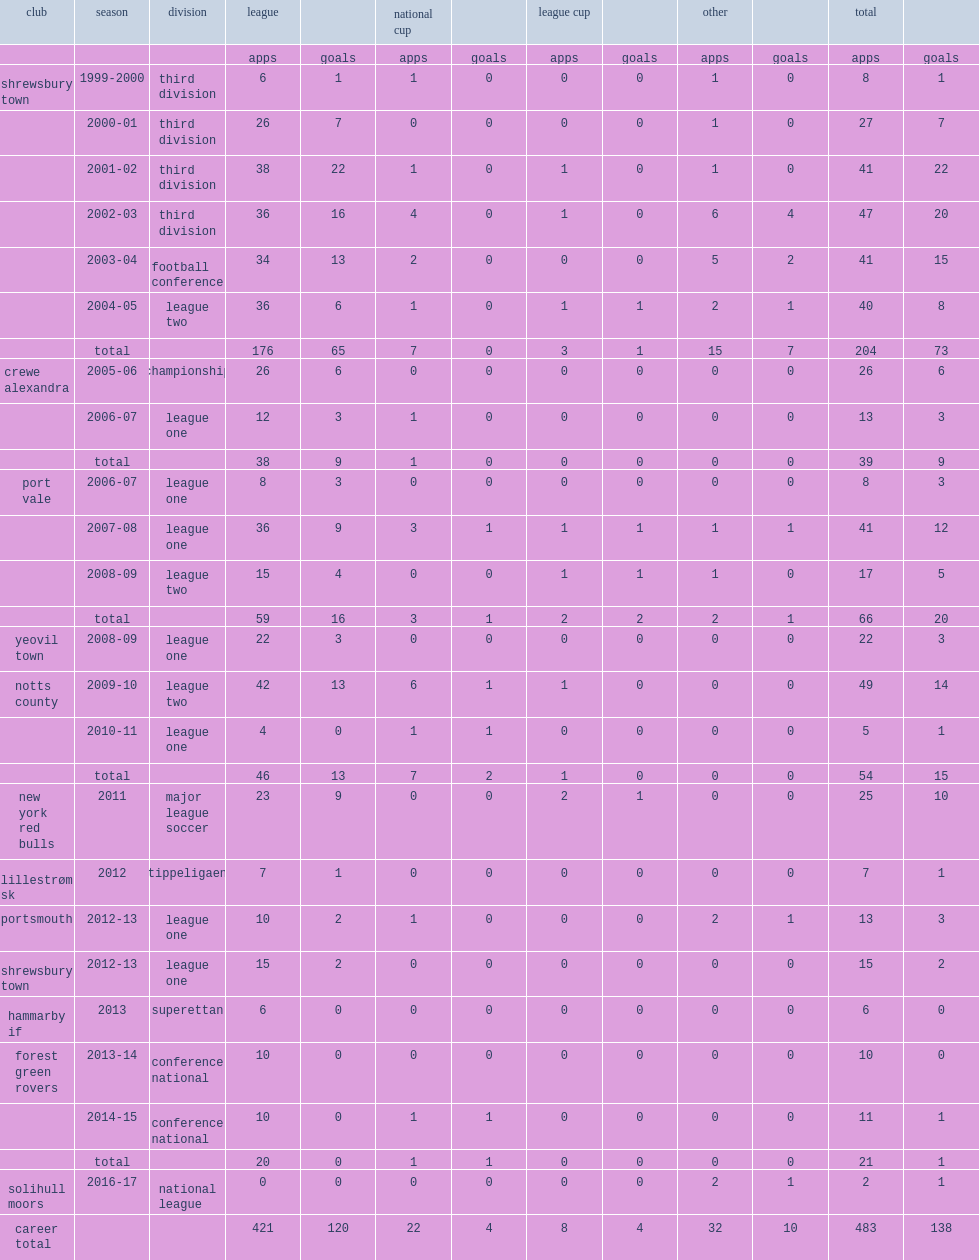Which club did rodgers play for in 2011? New york red bulls. 